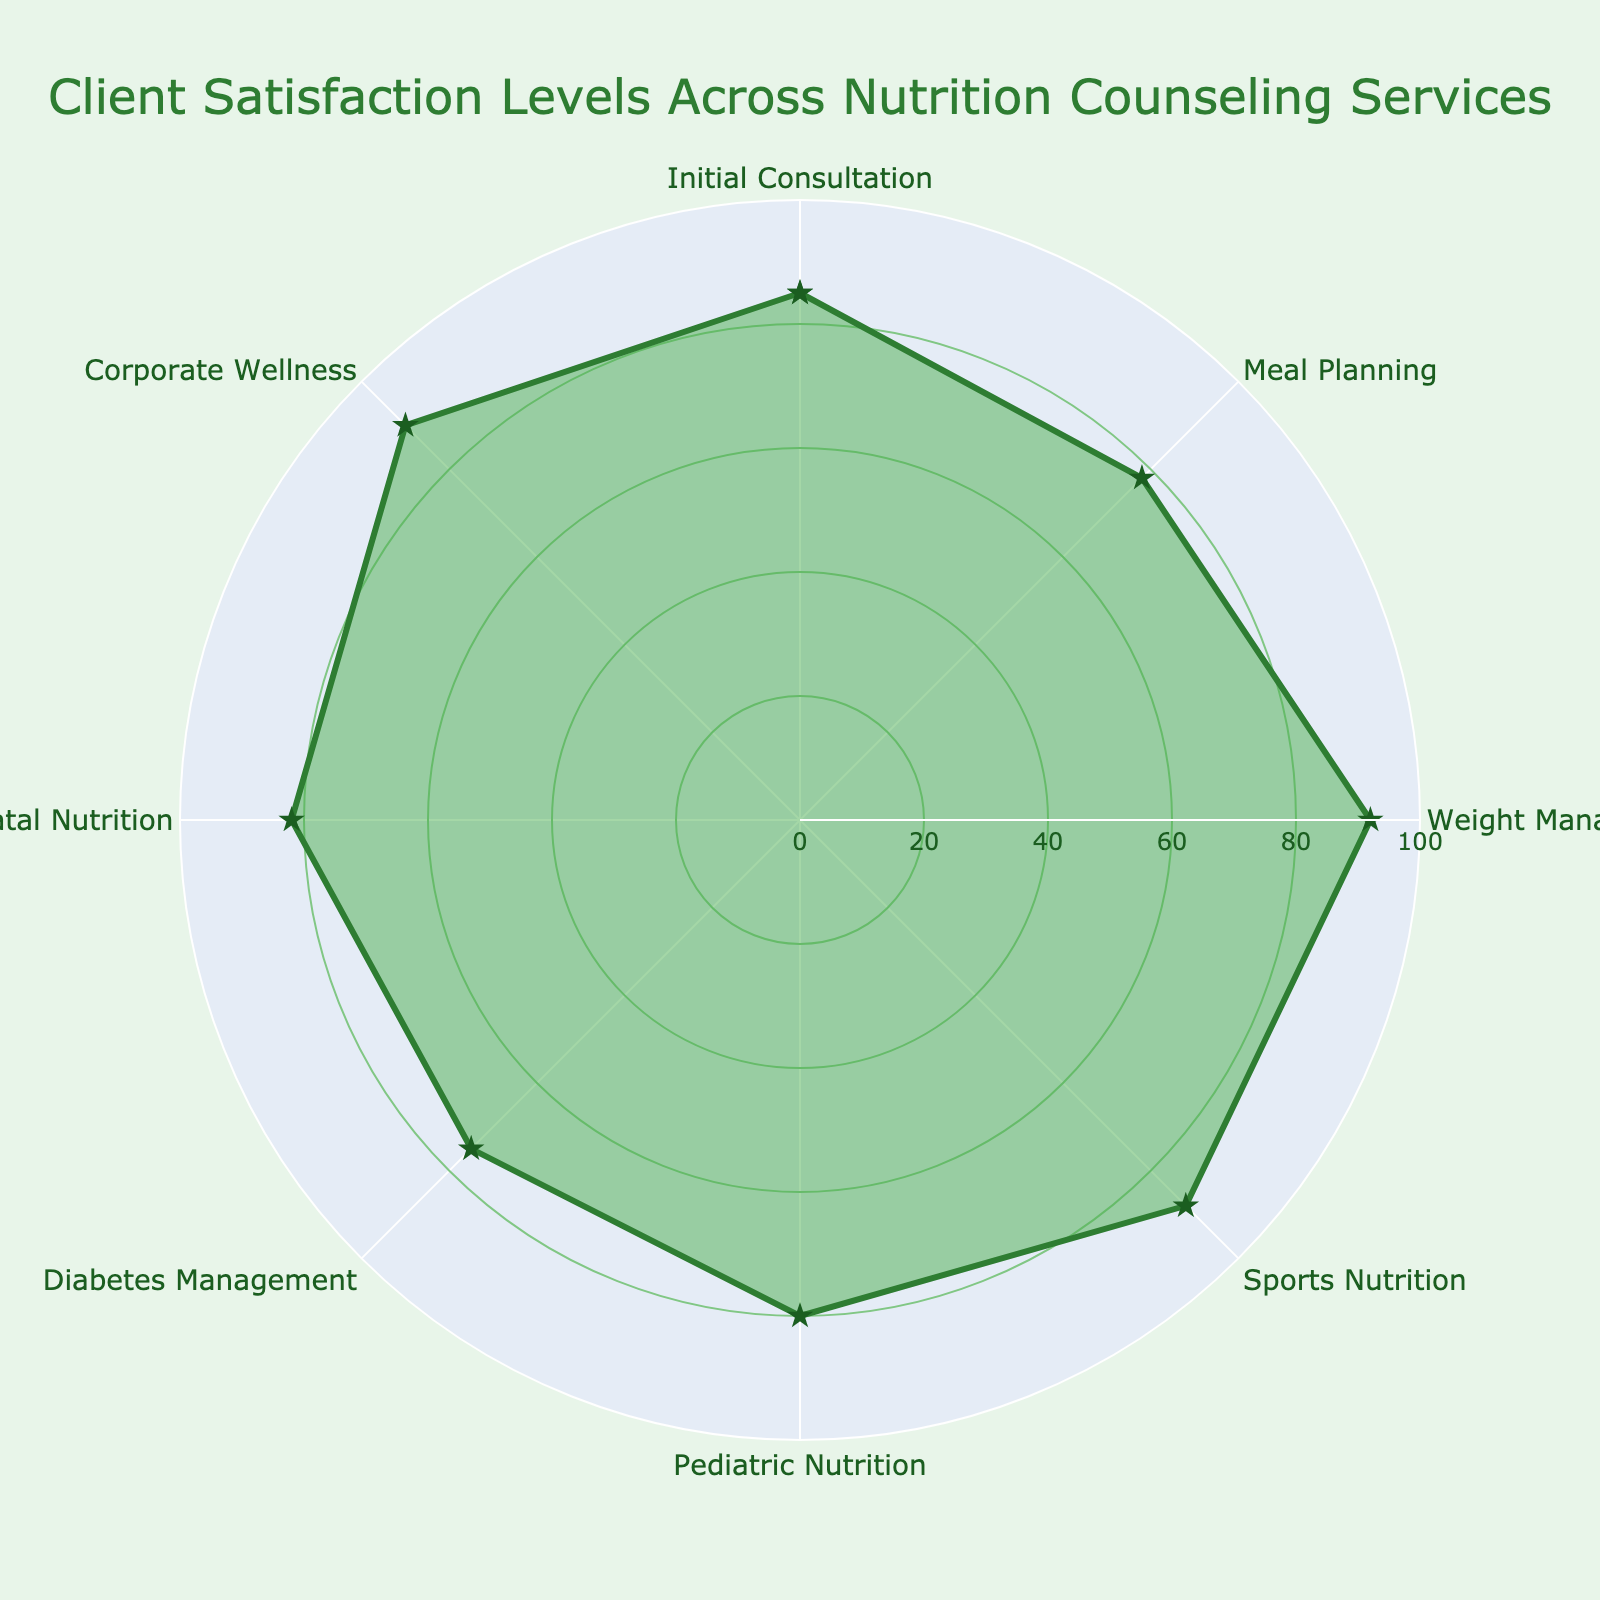What's the title of the radar chart? The title of the radar chart is usually displayed prominently at the top and indicates the purpose of the chart. From the given data, the title should be "Client Satisfaction Levels Across Nutrition Counseling Services."
Answer: Client Satisfaction Levels Across Nutrition Counseling Services Which service has the lowest client satisfaction level? To determine the service with the lowest client satisfaction, you need to look at the data points and identify the one with the smallest value. In this case, the lowest value is 75 for Diabetes Management.
Answer: Diabetes Management What is the range of client satisfaction levels in the radar chart? The range is calculated by subtracting the smallest value from the largest value. Here, the largest value is 92 (Weight Management) and the smallest value is 75 (Diabetes Management). So, the range is 92 - 75.
Answer: 17 How many services have client satisfaction levels above 80? To answer this, count the data points with values greater than 80. Initial Consultation (85), Weight Management (92), Sports Nutrition (88), Prenatal Nutrition (82), and Corporate Wellness (90) all have values above 80.
Answer: 5 Which services have client satisfaction levels between 75 and 85? Identify the services that fall within this range. Initial Consultation (85), Meal Planning (78), Pediatric Nutrition (80), and Prenatal Nutrition (82) fit the criteria.
Answer: Initial Consultation, Meal Planning, Pediatric Nutrition, Prenatal Nutrition What's the average client satisfaction level across all services? To find the average, sum up all the satisfaction levels and divide by the number of services. (85 + 78 + 92 + 88 + 80 + 75 + 82 + 90) / 8 = 84.75.
Answer: 84.75 Compare the client satisfaction levels of Sports Nutrition and Prenatal Nutrition. Which one is higher? Look at the values for both services. Sports Nutrition has a satisfaction level of 88, while Prenatal Nutrition has 82. Therefore, Sports Nutrition is higher.
Answer: Sports Nutrition How does the client satisfaction for Corporate Wellness compare to Weight Management? Both values need to be compared directly. Corporate Wellness has a satisfaction level of 90 and Weight Management has 92. Weight Management is higher.
Answer: Weight Management What is the median client satisfaction level? To find the median, list all values in ascending order and find the middle value. If there's an even number of values, average the two middle values. Ordered values: 75, 78, 80, 82, 85, 88, 90, 92. Middle values are 82 and 85, so (82 + 85) / 2 = 83.5.
Answer: 83.5 